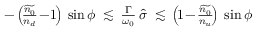<formula> <loc_0><loc_0><loc_500><loc_500>\begin{array} { r } { - \left ( \, \frac { \widetilde { n _ { 0 } } } { n _ { d } } \, - \, 1 \, \right ) \, \sin \phi \, \lesssim \, \frac { \Gamma } { \omega _ { 0 } } \, \hat { \sigma } \, \lesssim \, \left ( \, 1 \, - \, \frac { \widetilde { n _ { 0 } } } { n _ { u } } \, \right ) \, \sin \phi } \end{array}</formula> 